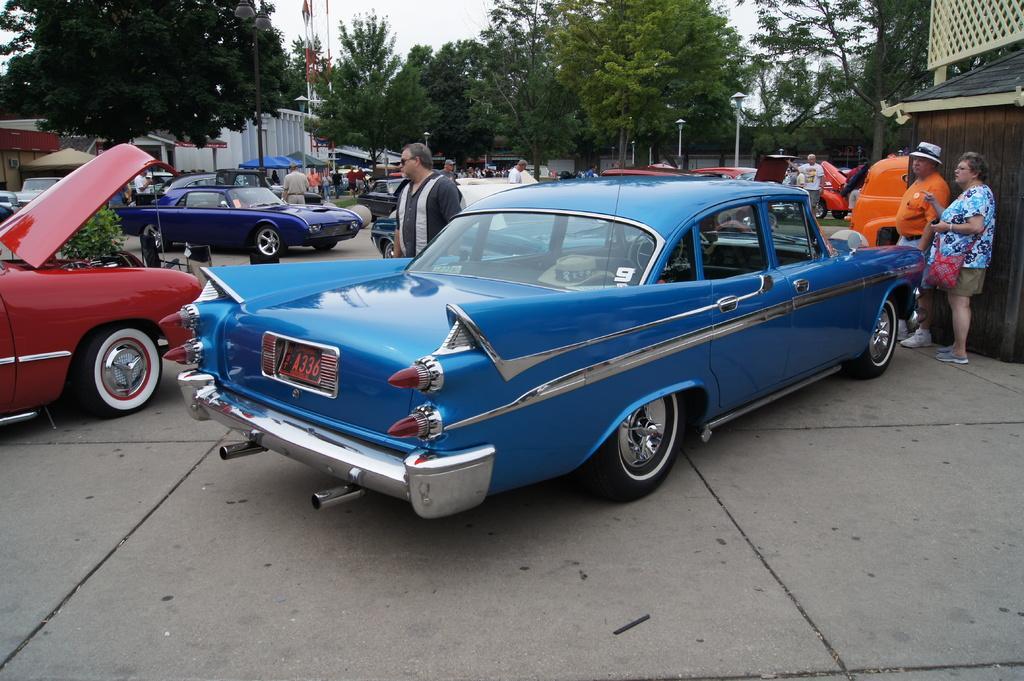Could you give a brief overview of what you see in this image? In this picture we can see some cars parked here, there are some people standing in the background, we can see some trees and poles here, there is grass here, we can see the sky at the top of the picture, we can see umbrellas here, on the right side there is a room. 